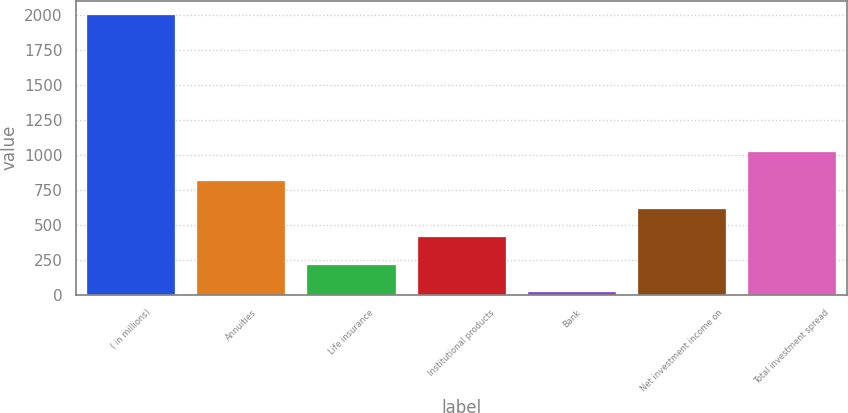Convert chart to OTSL. <chart><loc_0><loc_0><loc_500><loc_500><bar_chart><fcel>( in millions)<fcel>Annuities<fcel>Life insurance<fcel>Institutional products<fcel>Bank<fcel>Net investment income on<fcel>Total investment spread<nl><fcel>2006<fcel>812<fcel>215<fcel>414<fcel>16<fcel>613<fcel>1025<nl></chart> 